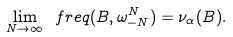<formula> <loc_0><loc_0><loc_500><loc_500>\lim _ { N \to \infty } \ f r e q ( B , \omega _ { - N } ^ { N } ) = \nu _ { \alpha } ( B ) .</formula> 